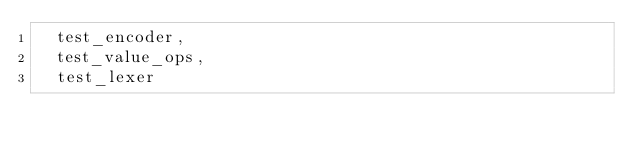<code> <loc_0><loc_0><loc_500><loc_500><_Nim_>  test_encoder,
  test_value_ops,
  test_lexer
</code> 